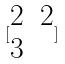Convert formula to latex. <formula><loc_0><loc_0><loc_500><loc_500>[ \begin{matrix} 2 & 2 \\ 3 \end{matrix} ]</formula> 